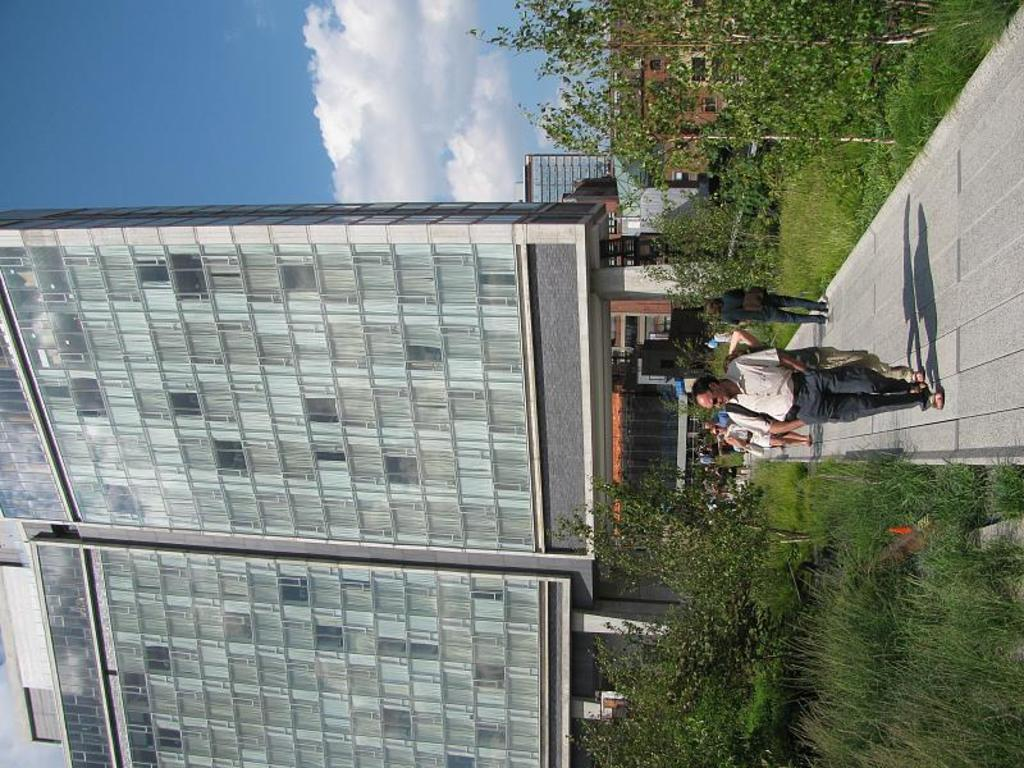What type of structures can be seen in the image? There are buildings in the image. What natural elements are present in the image? There are trees in the image. What are the people in the image doing? The people in the image are walking on a path. What is visible in the sky in the image? The sky is visible at the top of the image, with clouds. What type of ground surface is present at the bottom of the image? Grass is present at the bottom of the image. Where is the lace located in the image? There is no lace present in the image. What type of cave can be seen in the image? There is no cave present in the image. 